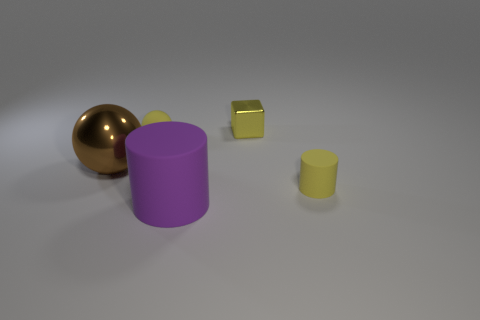Add 3 big yellow shiny cylinders. How many objects exist? 8 Subtract all blocks. How many objects are left? 4 Add 5 small metallic blocks. How many small metallic blocks are left? 6 Add 3 small yellow things. How many small yellow things exist? 6 Subtract 0 green balls. How many objects are left? 5 Subtract all yellow balls. Subtract all yellow rubber cylinders. How many objects are left? 3 